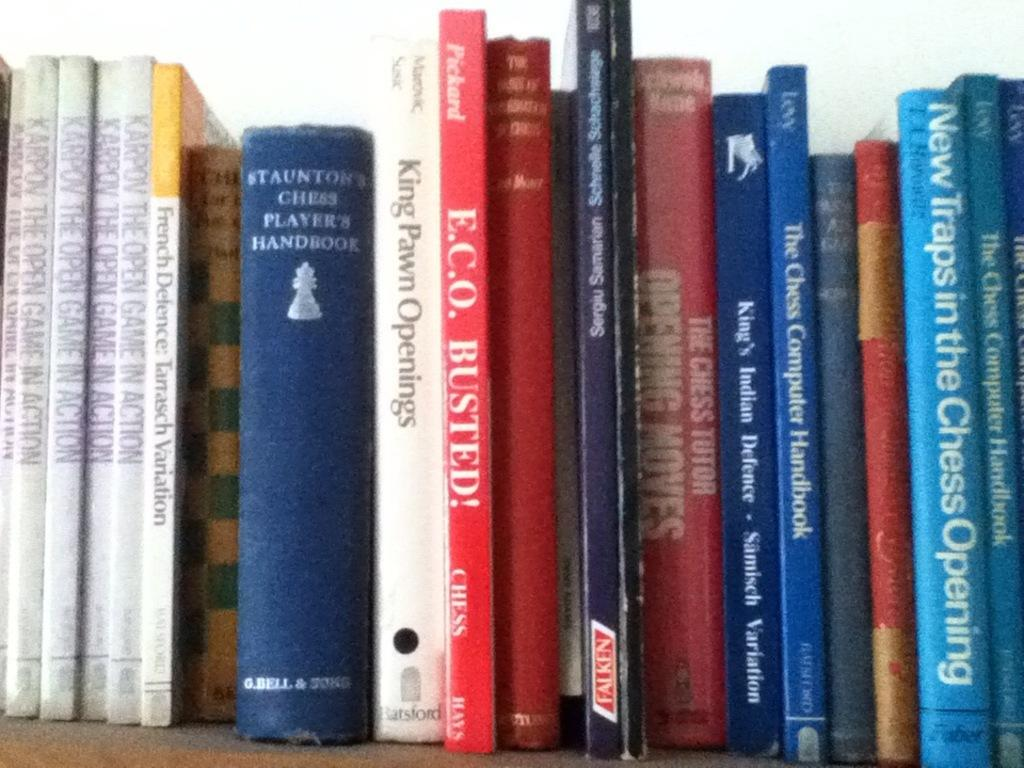<image>
Share a concise interpretation of the image provided. several books arranged on a shelf with different titles lik "king pawn openings". 